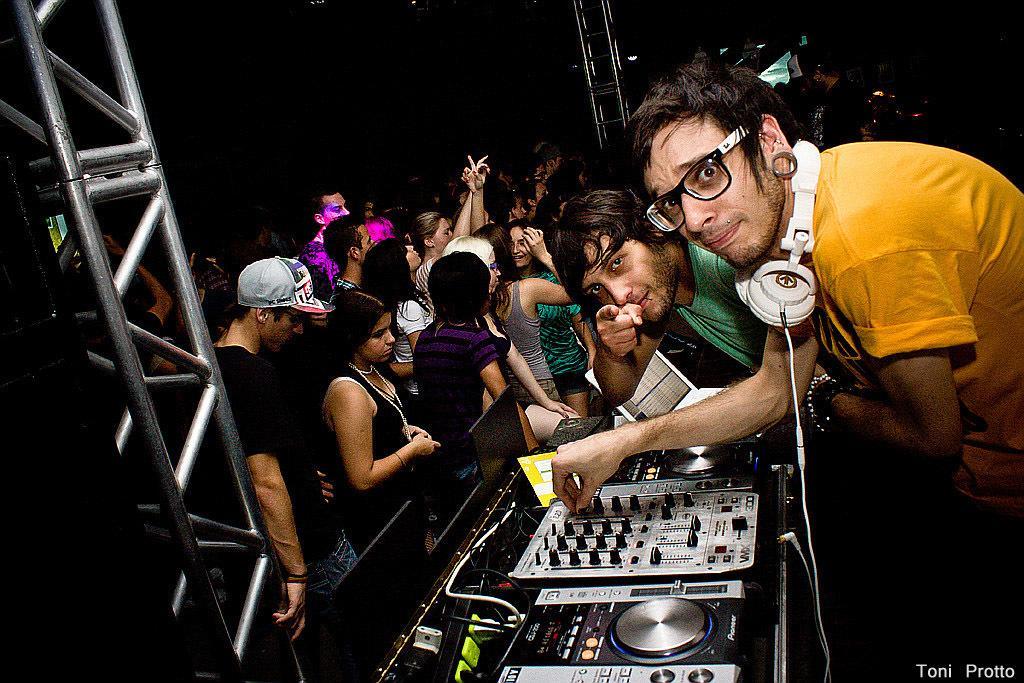In one or two sentences, can you explain what this image depicts? In this picture we can see the two boys in the front, smiling and giving a pose to the camera. In the front there is a music system. Behind we can see some people dancing. On the left corner there is a metal frame and dark background. 